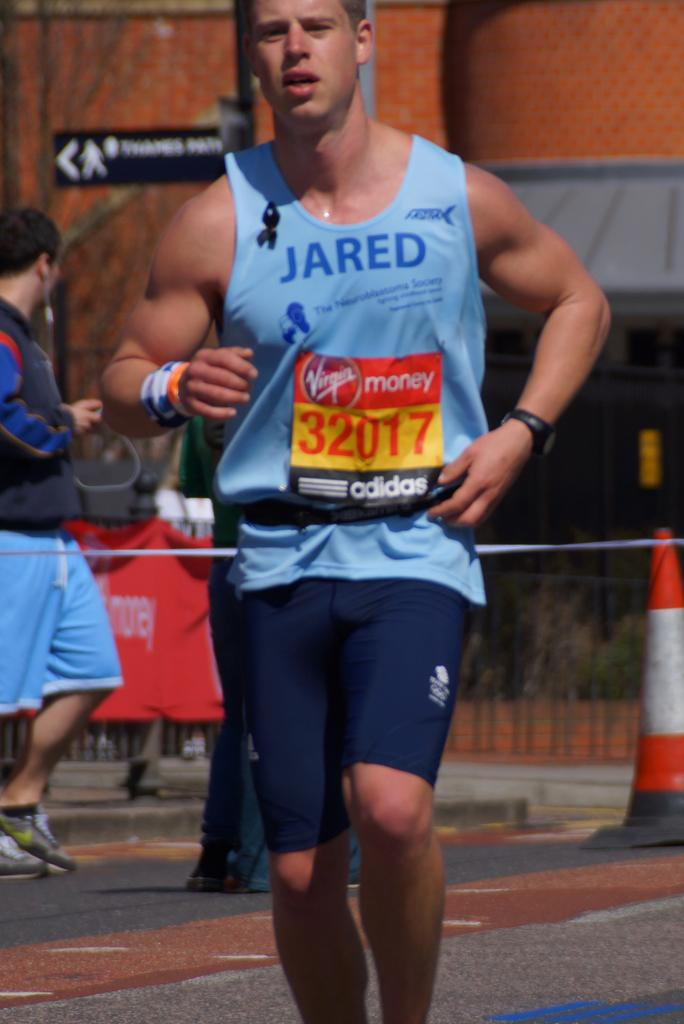<image>
Summarize the visual content of the image. A man runs in a race sponsored by Virgin Money and is competitor 32017 